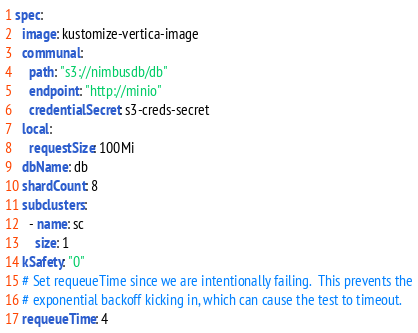Convert code to text. <code><loc_0><loc_0><loc_500><loc_500><_YAML_>spec:
  image: kustomize-vertica-image
  communal:
    path: "s3://nimbusdb/db"
    endpoint: "http://minio"
    credentialSecret: s3-creds-secret
  local:
    requestSize: 100Mi
  dbName: db
  shardCount: 8
  subclusters:
    - name: sc
      size: 1
  kSafety: "0"
  # Set requeueTime since we are intentionally failing.  This prevents the
  # exponential backoff kicking in, which can cause the test to timeout.
  requeueTime: 4
</code> 